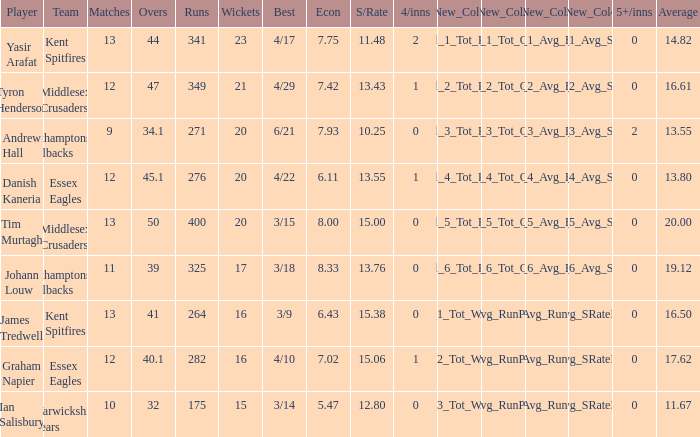Name the least matches for runs being 276 12.0. 